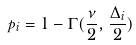Convert formula to latex. <formula><loc_0><loc_0><loc_500><loc_500>p _ { i } = 1 - \Gamma ( \frac { \nu } { 2 } , \frac { \Delta _ { i } } { 2 } )</formula> 